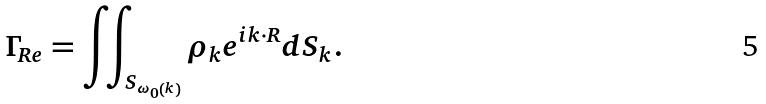Convert formula to latex. <formula><loc_0><loc_0><loc_500><loc_500>\Gamma _ { R e } = \iint _ { S _ { { \omega } _ { 0 } \left ( k \right ) } } { { { \rho } _ { k } e } ^ { i k \cdot R } d S _ { k } } .</formula> 